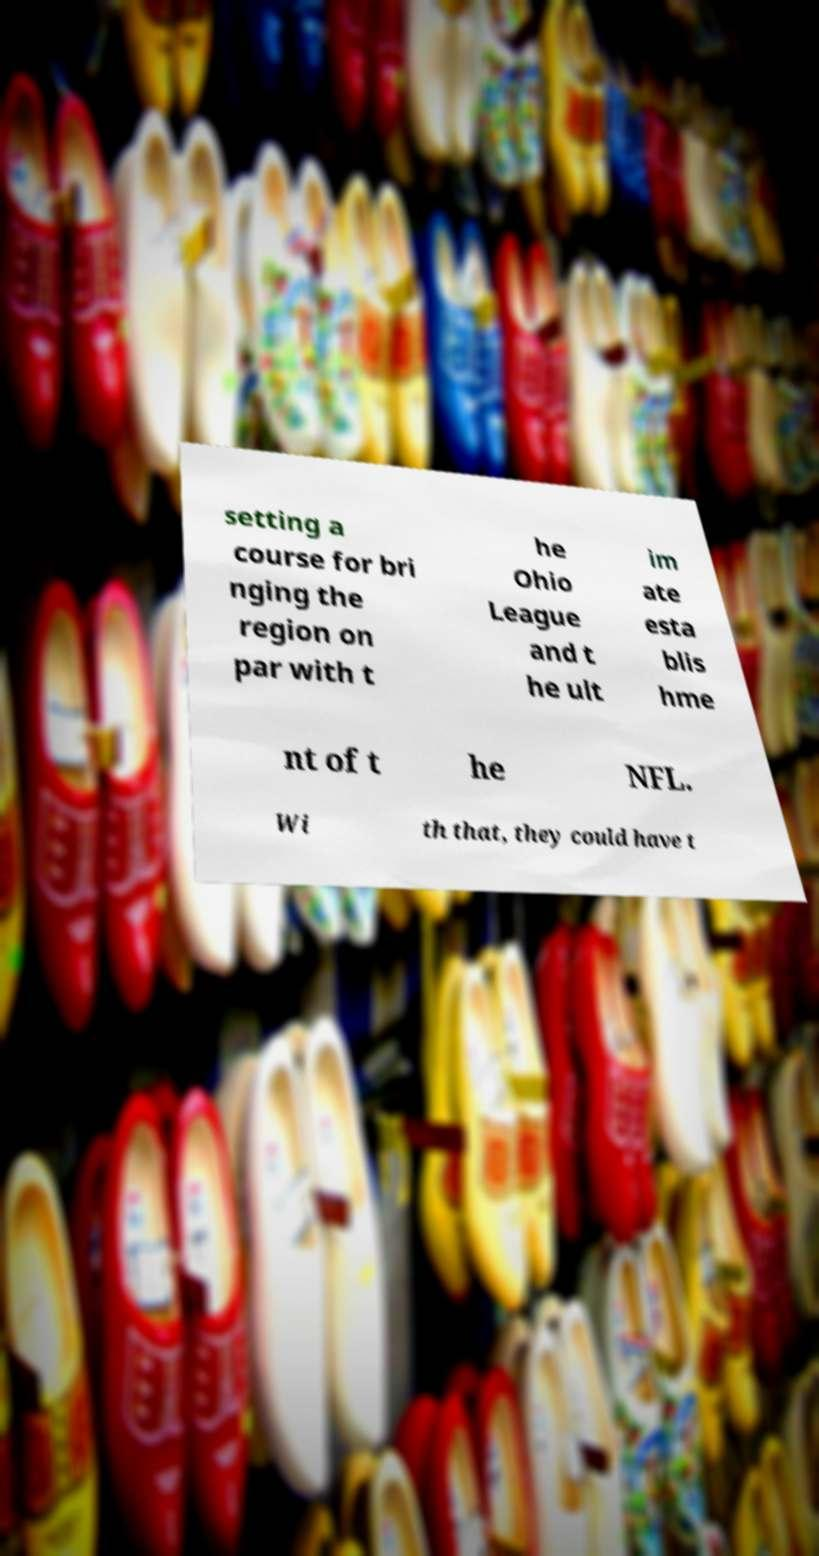For documentation purposes, I need the text within this image transcribed. Could you provide that? setting a course for bri nging the region on par with t he Ohio League and t he ult im ate esta blis hme nt of t he NFL. Wi th that, they could have t 